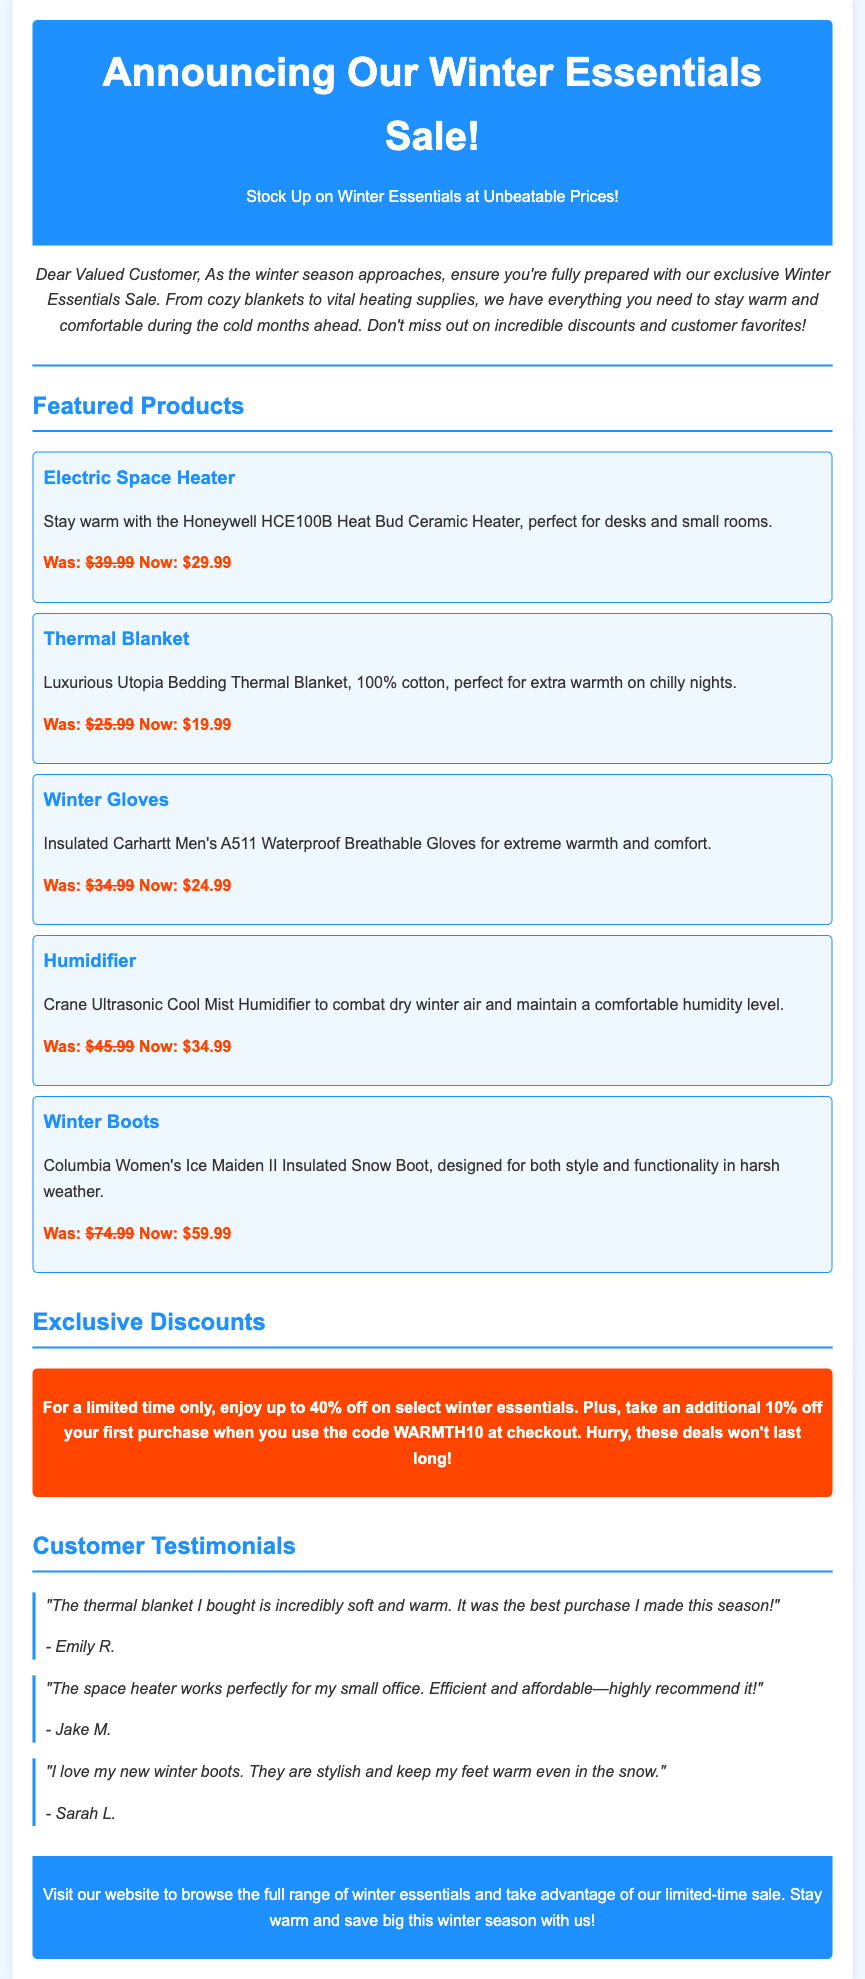What is the title of the newsletter? The title at the top of the document is the main heading that summarizes the content of the newsletter.
Answer: Announcing Our Winter Essentials Sale! What is the price of the Electric Space Heater after the discount? The price listed after the strike-through original price indicates the current discounted price of the product.
Answer: $29.99 Which coupon code gives an additional discount on the first purchase? The code mentioned in the exclusive discounts section provides an additional discount for new customers.
Answer: WARMTH10 What is the maximum discount available on select winter essentials? The section on exclusive discounts states the maximum percentage that can be saved on selected items.
Answer: 40% Who said the thermal blanket is incredibly soft and warm? The testimonial section includes customer feedback, including who made the positive remark about the blanket.
Answer: Emily R What type of product is the Crane Ultrasonic Cool Mist? The product category is directly referenced in the detailed description provided under the featured products section.
Answer: Humidifier Which product is designed for extreme warmth and comfort? The reasoning involves looking at the descriptions of the products to determine which one specifically mentions extreme warmth and comfort.
Answer: Winter Gloves What is the original price of the Thermal Blanket? The original price can be found by looking for the strike-through amount next to the discounted price in the product description.
Answer: $25.99 How many customer testimonials are included in the newsletter? The total count of testimonials can be obtained by looking through the testimonial section of the document for the number of entries.
Answer: 3 